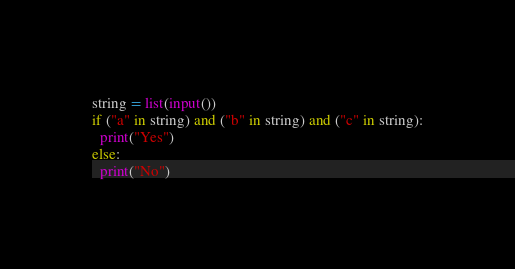<code> <loc_0><loc_0><loc_500><loc_500><_Python_>string = list(input())
if ("a" in string) and ("b" in string) and ("c" in string):
  print("Yes")
else:
  print("No")</code> 